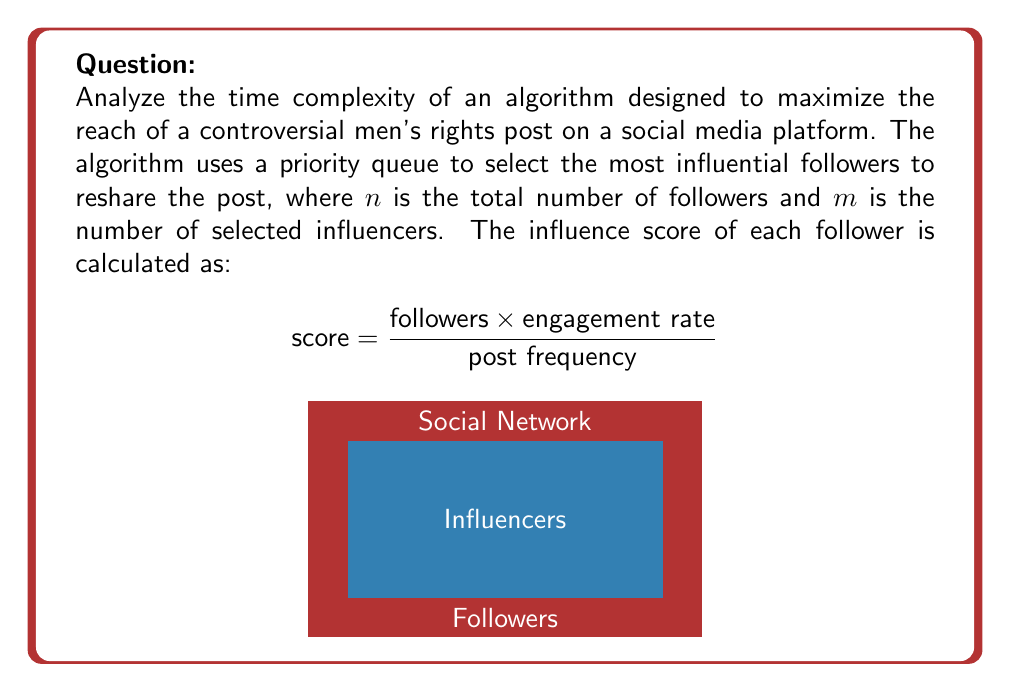Can you solve this math problem? To analyze the time complexity of this algorithm, we need to consider the main operations:

1. Calculating influence scores:
   - This requires iterating through all n followers once.
   - Time complexity: $O(n)$

2. Building the priority queue:
   - Inserting n elements into a priority queue.
   - Time complexity: $O(n \log n)$

3. Selecting m influencers:
   - Extracting the top m elements from the priority queue.
   - Each extraction takes $O(\log n)$ time.
   - Repeated m times.
   - Time complexity: $O(m \log n)$

4. Resharing the post:
   - Assuming constant time for each reshare.
   - Time complexity: $O(m)$

The total time complexity is the sum of these operations:

$$ T(n,m) = O(n) + O(n \log n) + O(m \log n) + O(m) $$

Simplifying:
$$ T(n,m) = O(n \log n + m \log n) $$

Since $m \leq n$ (we can't select more influencers than we have followers), the dominant term is $n \log n$.

Therefore, the overall time complexity of the algorithm is $O(n \log n)$.
Answer: $O(n \log n)$ 